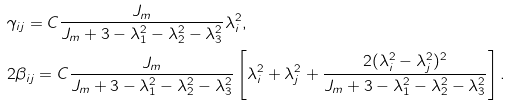<formula> <loc_0><loc_0><loc_500><loc_500>& \gamma _ { i j } = C \frac { J _ { m } } { J _ { m } + 3 - \lambda _ { 1 } ^ { 2 } - \lambda _ { 2 } ^ { 2 } - \lambda _ { 3 } ^ { 2 } } \lambda _ { i } ^ { 2 } , \\ & 2 \beta _ { i j } = C \frac { J _ { m } } { J _ { m } + 3 - \lambda _ { 1 } ^ { 2 } - \lambda _ { 2 } ^ { 2 } - \lambda _ { 3 } ^ { 2 } } \left [ \lambda _ { i } ^ { 2 } + \lambda _ { j } ^ { 2 } + \frac { 2 ( \lambda _ { i } ^ { 2 } - \lambda _ { j } ^ { 2 } ) ^ { 2 } } { J _ { m } + 3 - \lambda _ { 1 } ^ { 2 } - \lambda _ { 2 } ^ { 2 } - \lambda _ { 3 } ^ { 2 } } \right ] .</formula> 